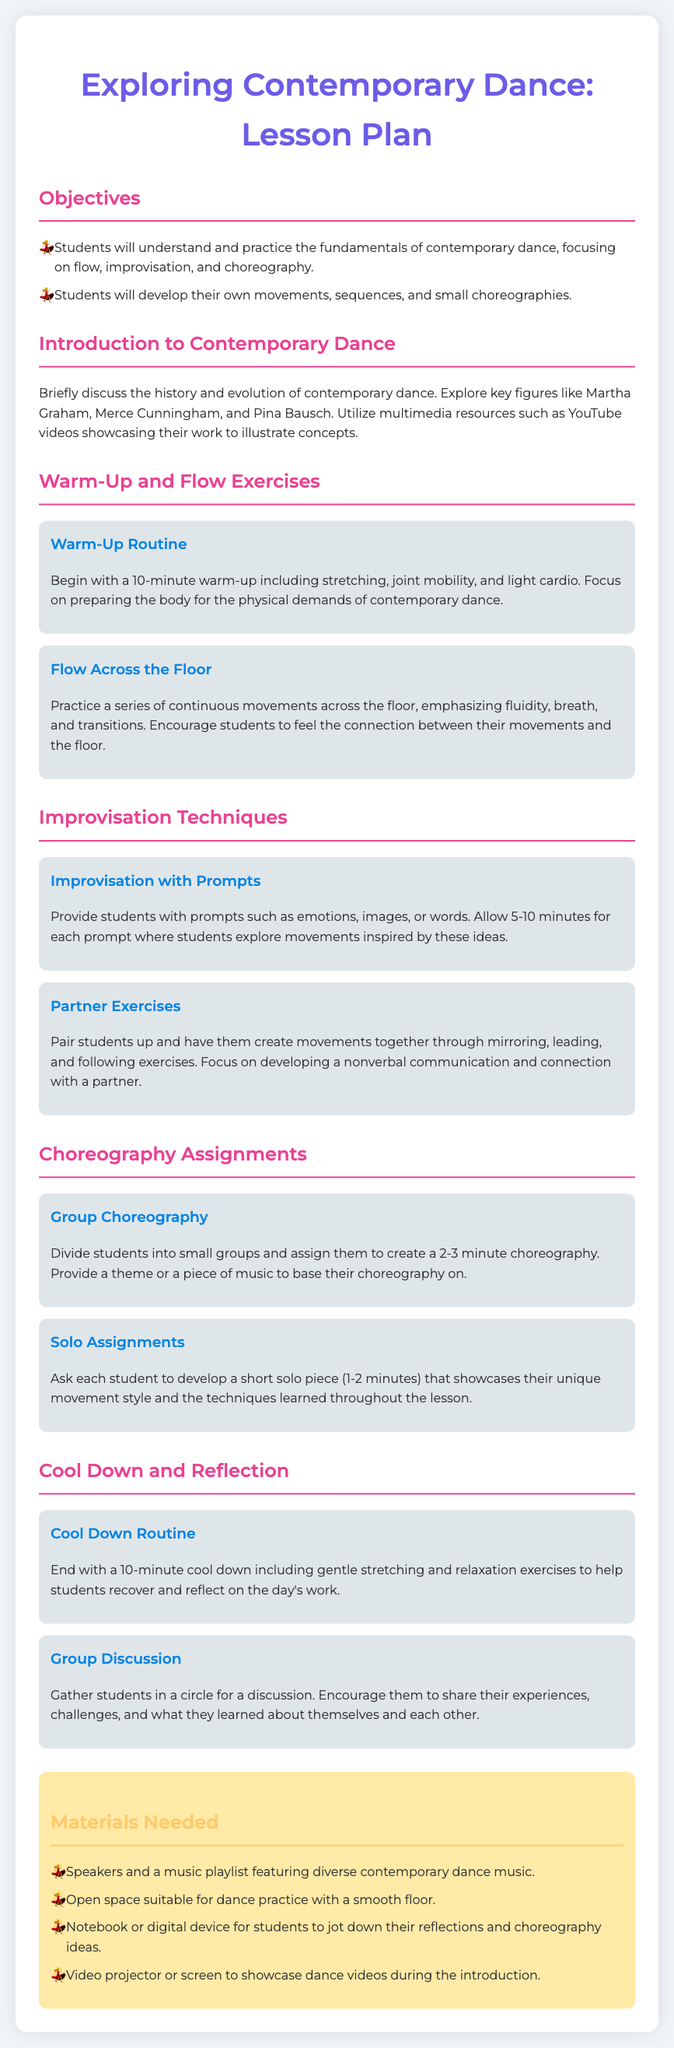What are the key figures in contemporary dance? The document mentions key figures like Martha Graham, Merce Cunningham, and Pina Bausch as influential in contemporary dance.
Answer: Martha Graham, Merce Cunningham, Pina Bausch What is the duration of the warm-up routine? The warm-up routine is specified to last for 10 minutes.
Answer: 10 minutes How long should the group choreography be? The lesson plan states that the group choreography should last for 2-3 minutes.
Answer: 2-3 minutes What is one of the goals for solo assignments? The goal for solo assignments is for each student to showcase their unique movement style.
Answer: showcase their unique movement style What is included in the cool down routine? The cool down routine includes gentle stretching and relaxation exercises.
Answer: gentle stretching and relaxation exercises What is the purpose of the group discussion? The purpose of the group discussion is for students to share their experiences, challenges, and what they learned.
Answer: share their experiences, challenges, and what they learned What materials are needed for the lesson? The materials needed include speakers and a music playlist featuring diverse contemporary dance music.
Answer: speakers and a music playlist What are the main focus areas in this lesson plan? The main focus areas are flow, improvisation, and choreography.
Answer: flow, improvisation, and choreography What type of exercises are used for partner work? The partner exercises involve activities like mirroring, leading, and following.
Answer: mirroring, leading, and following 